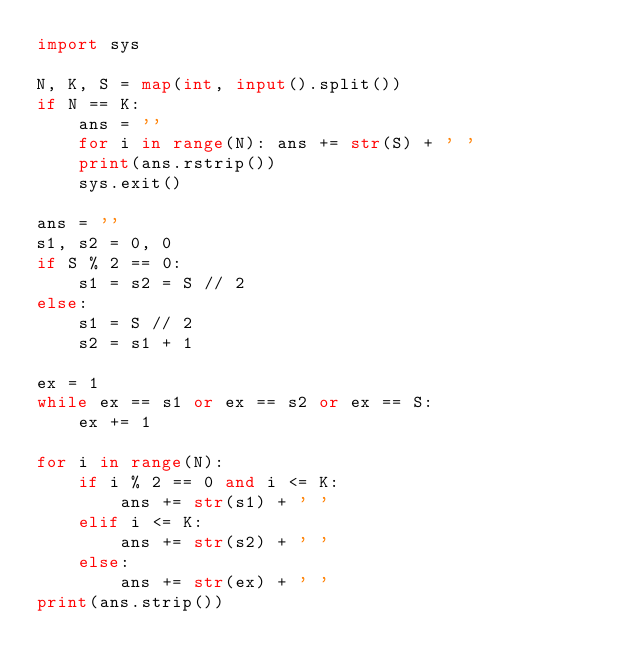Convert code to text. <code><loc_0><loc_0><loc_500><loc_500><_Python_>import sys

N, K, S = map(int, input().split())
if N == K:
    ans = ''
    for i in range(N): ans += str(S) + ' '
    print(ans.rstrip())
    sys.exit()

ans = ''
s1, s2 = 0, 0
if S % 2 == 0:
    s1 = s2 = S // 2
else:
    s1 = S // 2
    s2 = s1 + 1

ex = 1
while ex == s1 or ex == s2 or ex == S:
    ex += 1

for i in range(N):
    if i % 2 == 0 and i <= K:
        ans += str(s1) + ' '
    elif i <= K:
        ans += str(s2) + ' '
    else:
        ans += str(ex) + ' '
print(ans.strip())
</code> 